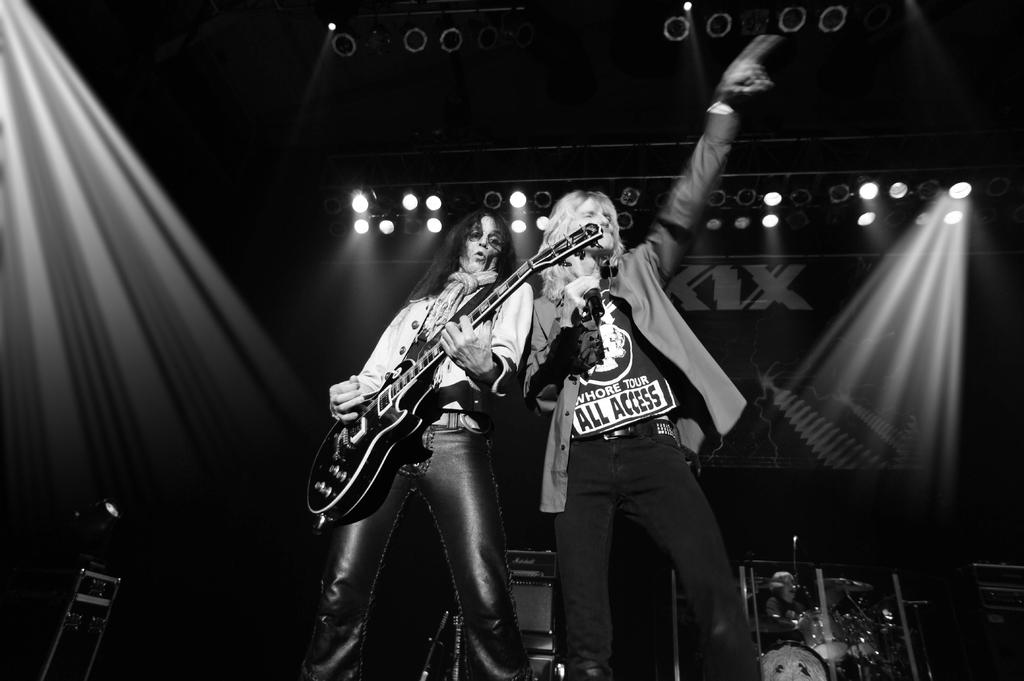What is the color scheme of the image? The image is black and white. What is the woman in the image doing? The woman is playing a guitar in the image. What is the man in the image doing? The man is singing in front of a mic in the image. What type of lighting is visible in the image? There are focusing lights visible in the image. What type of wood is the sail made of in the image? There is no sail present in the image; it features a woman playing a guitar and a man singing in front of a mic. How many toes can be seen on the woman's feet in the image? The image does not show the woman's feet, so it is not possible to determine the number of toes visible. 